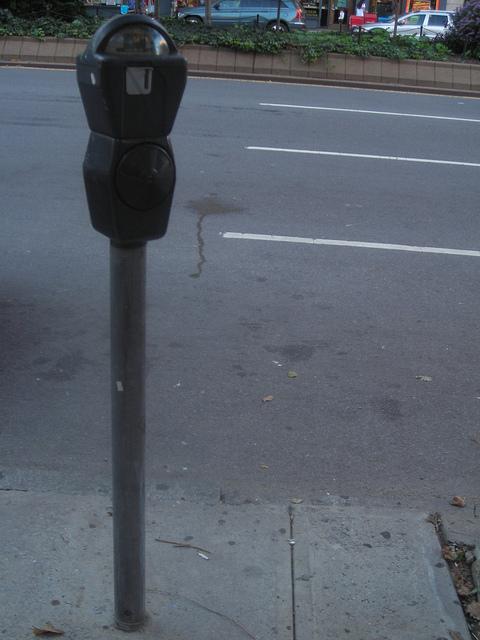Is it daytime?
Concise answer only. Yes. Is the road clear?
Give a very brief answer. Yes. How many cups are there?
Answer briefly. 0. What color is this parking meter?
Give a very brief answer. Gray. How many parking meters are there?
Give a very brief answer. 1. Are there any parked cars in front of the parking meter?
Short answer required. No. Is there wig on this parking meter?
Concise answer only. No. Can you see rust on the parking meter pole?
Give a very brief answer. No. 